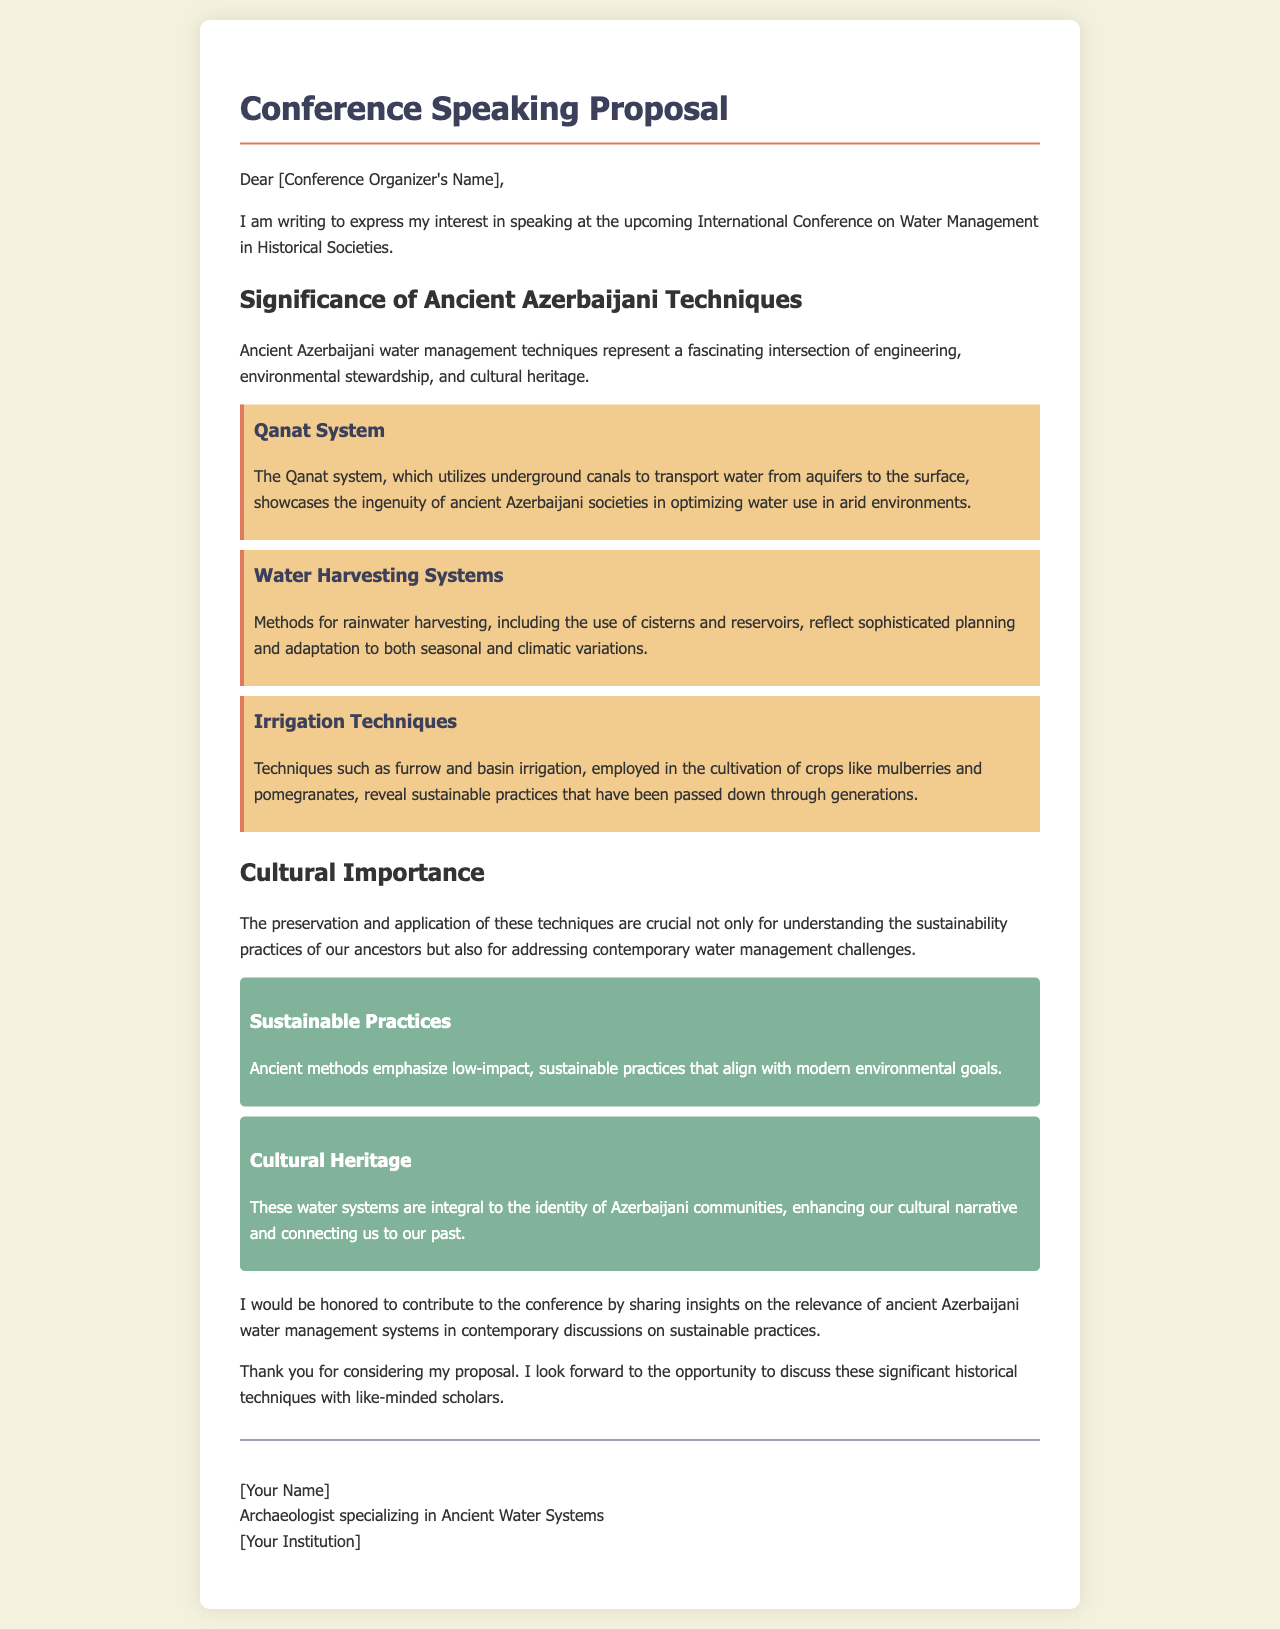What is the title of the conference? The title of the conference is mentioned in the greeting section of the letter.
Answer: International Conference on Water Management in Historical Societies Who is the intended audience of the conference? The intended audience is implied by the focus of the document, particularly in terms of scholarly engagement.
Answer: Scholars What is one ancient Azerbaijani water management technique mentioned? The techniques are listed under their respective headings in the significance section.
Answer: Qanat System What kind of irrigation techniques are discussed? The document specifies types of irrigation techniques as a part of its content.
Answer: Furrow and basin irrigation What does the Qanat system optimize? The Qanat system's purpose is discussed in the document in relation to its functionality.
Answer: Water use What agricultural crops are mentioned in the irrigation section? The specific crops listed in the document provide the context for irrigation methods.
Answer: Mulberries and pomegranates What is highlighted as an aspect of cultural importance? Cultural significance is mentioned in relation to the techniques discussed in the document.
Answer: Cultural heritage What theme does the author wish to contribute to at the conference? The author expresses a specific focus on contemporary issues related to historical techniques.
Answer: Sustainable practices 